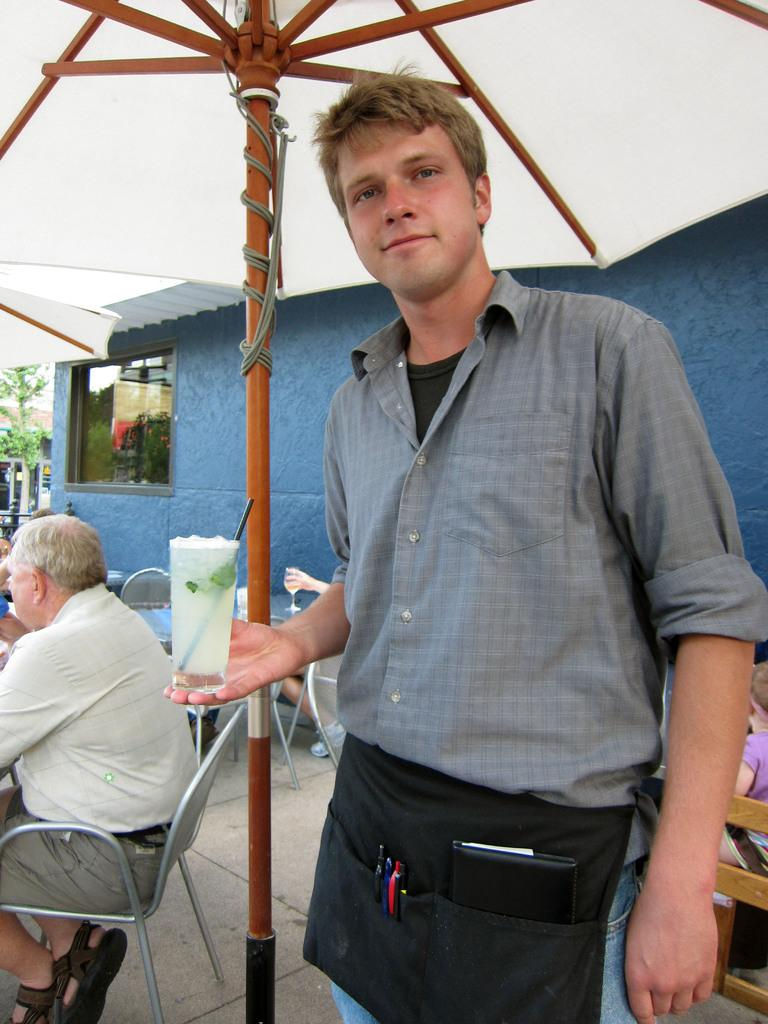What is the man in the image doing? The man is standing in the image and holding a glass in his hand. What are the people in the image doing? The people in the image are seated on chairs. What type of structure is visible in the image? There is a house in the image. What object is present in the image that can provide shade or protection from the rain? There is an umbrella in the image. What type of plant is visible in the image? There is a tree in the image. What type of bushes can be seen growing around the house in the image? There is no mention of bushes in the provided facts, so we cannot determine if there are any bushes around the house in the image. What dish is the cook preparing in the image? There is no cook or dish preparation mentioned in the provided facts, so we cannot answer this question. 